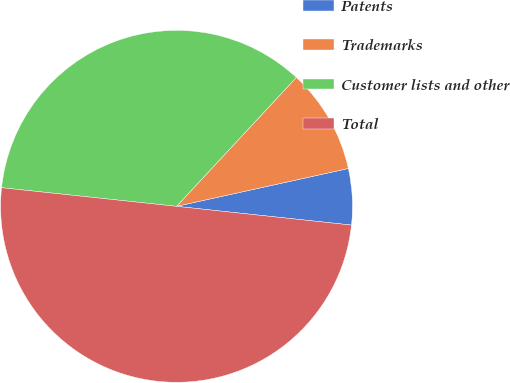Convert chart to OTSL. <chart><loc_0><loc_0><loc_500><loc_500><pie_chart><fcel>Patents<fcel>Trademarks<fcel>Customer lists and other<fcel>Total<nl><fcel>5.15%<fcel>9.63%<fcel>35.23%<fcel>49.99%<nl></chart> 